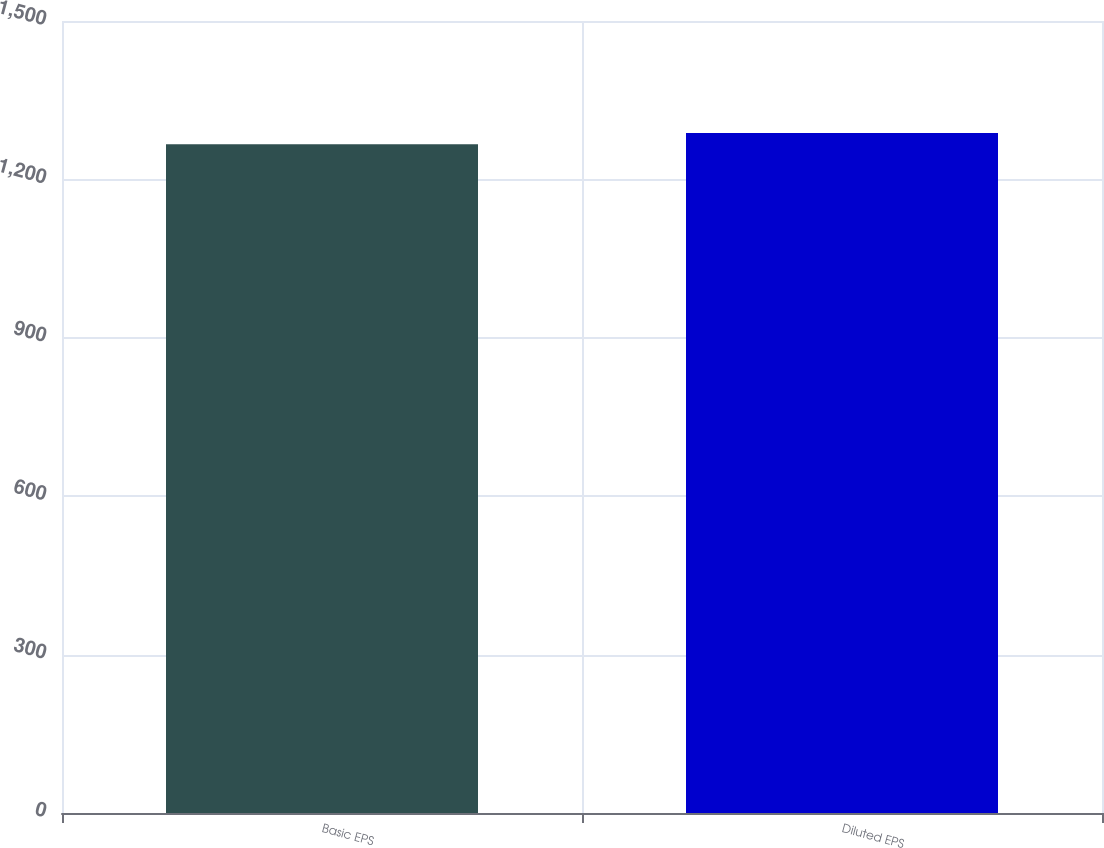Convert chart. <chart><loc_0><loc_0><loc_500><loc_500><bar_chart><fcel>Basic EPS<fcel>Diluted EPS<nl><fcel>1266.4<fcel>1287.9<nl></chart> 